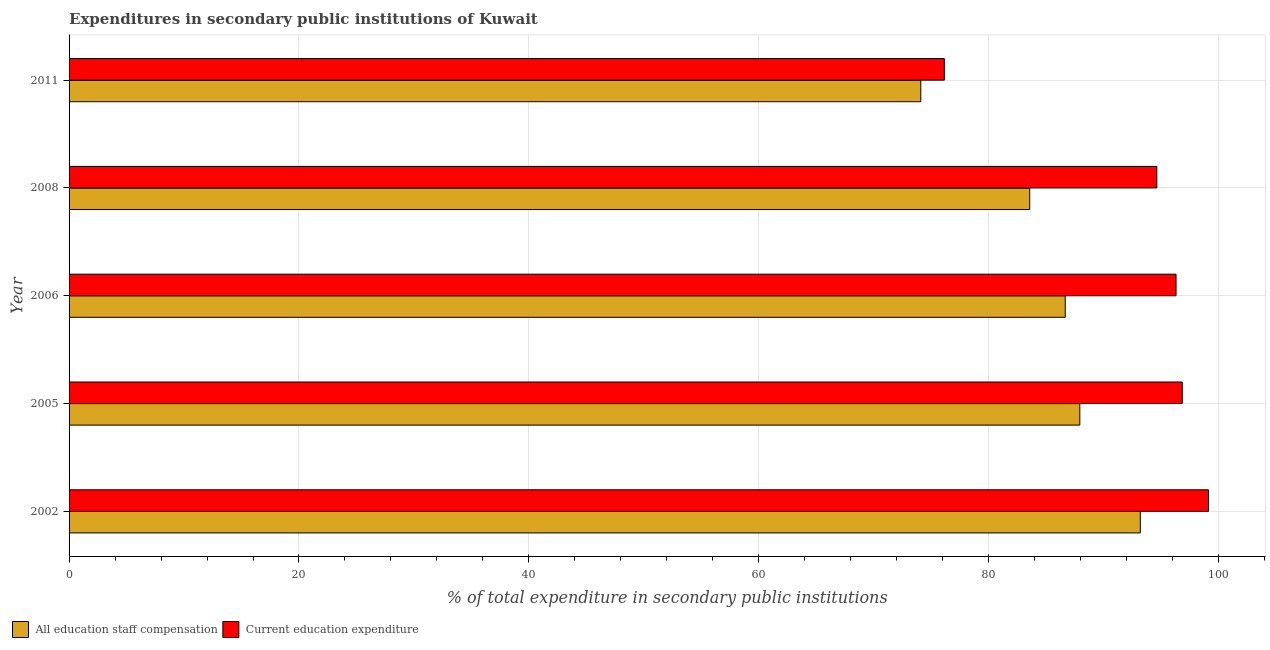How many groups of bars are there?
Offer a very short reply. 5. Are the number of bars on each tick of the Y-axis equal?
Your answer should be very brief. Yes. What is the label of the 3rd group of bars from the top?
Provide a short and direct response. 2006. In how many cases, is the number of bars for a given year not equal to the number of legend labels?
Provide a succinct answer. 0. What is the expenditure in staff compensation in 2008?
Your answer should be compact. 83.57. Across all years, what is the maximum expenditure in staff compensation?
Keep it short and to the point. 93.19. Across all years, what is the minimum expenditure in staff compensation?
Offer a very short reply. 74.09. What is the total expenditure in staff compensation in the graph?
Give a very brief answer. 425.45. What is the difference between the expenditure in education in 2008 and that in 2011?
Your answer should be compact. 18.49. What is the difference between the expenditure in education in 2002 and the expenditure in staff compensation in 2005?
Make the answer very short. 11.2. What is the average expenditure in education per year?
Offer a terse response. 92.61. In the year 2005, what is the difference between the expenditure in education and expenditure in staff compensation?
Provide a short and direct response. 8.91. In how many years, is the expenditure in staff compensation greater than 56 %?
Provide a short and direct response. 5. What is the ratio of the expenditure in staff compensation in 2006 to that in 2011?
Your response must be concise. 1.17. Is the expenditure in staff compensation in 2008 less than that in 2011?
Make the answer very short. No. Is the difference between the expenditure in education in 2006 and 2011 greater than the difference between the expenditure in staff compensation in 2006 and 2011?
Your answer should be compact. Yes. What is the difference between the highest and the second highest expenditure in education?
Your answer should be very brief. 2.28. What does the 2nd bar from the top in 2005 represents?
Your answer should be compact. All education staff compensation. What does the 1st bar from the bottom in 2011 represents?
Your answer should be compact. All education staff compensation. Are all the bars in the graph horizontal?
Keep it short and to the point. Yes. How many years are there in the graph?
Your answer should be very brief. 5. What is the difference between two consecutive major ticks on the X-axis?
Give a very brief answer. 20. Are the values on the major ticks of X-axis written in scientific E-notation?
Make the answer very short. No. Does the graph contain any zero values?
Keep it short and to the point. No. Where does the legend appear in the graph?
Your answer should be compact. Bottom left. How are the legend labels stacked?
Offer a terse response. Horizontal. What is the title of the graph?
Provide a succinct answer. Expenditures in secondary public institutions of Kuwait. Does "Non-resident workers" appear as one of the legend labels in the graph?
Offer a very short reply. No. What is the label or title of the X-axis?
Your response must be concise. % of total expenditure in secondary public institutions. What is the label or title of the Y-axis?
Keep it short and to the point. Year. What is the % of total expenditure in secondary public institutions of All education staff compensation in 2002?
Your response must be concise. 93.19. What is the % of total expenditure in secondary public institutions of Current education expenditure in 2002?
Offer a terse response. 99.12. What is the % of total expenditure in secondary public institutions in All education staff compensation in 2005?
Provide a succinct answer. 87.93. What is the % of total expenditure in secondary public institutions in Current education expenditure in 2005?
Provide a succinct answer. 96.84. What is the % of total expenditure in secondary public institutions of All education staff compensation in 2006?
Provide a succinct answer. 86.66. What is the % of total expenditure in secondary public institutions in Current education expenditure in 2006?
Your answer should be compact. 96.3. What is the % of total expenditure in secondary public institutions of All education staff compensation in 2008?
Offer a very short reply. 83.57. What is the % of total expenditure in secondary public institutions of Current education expenditure in 2008?
Provide a succinct answer. 94.63. What is the % of total expenditure in secondary public institutions of All education staff compensation in 2011?
Offer a terse response. 74.09. What is the % of total expenditure in secondary public institutions of Current education expenditure in 2011?
Make the answer very short. 76.14. Across all years, what is the maximum % of total expenditure in secondary public institutions in All education staff compensation?
Provide a short and direct response. 93.19. Across all years, what is the maximum % of total expenditure in secondary public institutions in Current education expenditure?
Give a very brief answer. 99.12. Across all years, what is the minimum % of total expenditure in secondary public institutions of All education staff compensation?
Ensure brevity in your answer.  74.09. Across all years, what is the minimum % of total expenditure in secondary public institutions in Current education expenditure?
Your response must be concise. 76.14. What is the total % of total expenditure in secondary public institutions in All education staff compensation in the graph?
Ensure brevity in your answer.  425.45. What is the total % of total expenditure in secondary public institutions of Current education expenditure in the graph?
Your answer should be very brief. 463.04. What is the difference between the % of total expenditure in secondary public institutions in All education staff compensation in 2002 and that in 2005?
Provide a succinct answer. 5.26. What is the difference between the % of total expenditure in secondary public institutions in Current education expenditure in 2002 and that in 2005?
Keep it short and to the point. 2.28. What is the difference between the % of total expenditure in secondary public institutions of All education staff compensation in 2002 and that in 2006?
Offer a very short reply. 6.53. What is the difference between the % of total expenditure in secondary public institutions in Current education expenditure in 2002 and that in 2006?
Make the answer very short. 2.83. What is the difference between the % of total expenditure in secondary public institutions of All education staff compensation in 2002 and that in 2008?
Offer a very short reply. 9.62. What is the difference between the % of total expenditure in secondary public institutions of Current education expenditure in 2002 and that in 2008?
Keep it short and to the point. 4.5. What is the difference between the % of total expenditure in secondary public institutions in All education staff compensation in 2002 and that in 2011?
Give a very brief answer. 19.1. What is the difference between the % of total expenditure in secondary public institutions in Current education expenditure in 2002 and that in 2011?
Provide a short and direct response. 22.98. What is the difference between the % of total expenditure in secondary public institutions of All education staff compensation in 2005 and that in 2006?
Make the answer very short. 1.27. What is the difference between the % of total expenditure in secondary public institutions in Current education expenditure in 2005 and that in 2006?
Your response must be concise. 0.54. What is the difference between the % of total expenditure in secondary public institutions of All education staff compensation in 2005 and that in 2008?
Your answer should be very brief. 4.36. What is the difference between the % of total expenditure in secondary public institutions of Current education expenditure in 2005 and that in 2008?
Your answer should be compact. 2.21. What is the difference between the % of total expenditure in secondary public institutions in All education staff compensation in 2005 and that in 2011?
Provide a short and direct response. 13.83. What is the difference between the % of total expenditure in secondary public institutions of Current education expenditure in 2005 and that in 2011?
Give a very brief answer. 20.7. What is the difference between the % of total expenditure in secondary public institutions of All education staff compensation in 2006 and that in 2008?
Your response must be concise. 3.09. What is the difference between the % of total expenditure in secondary public institutions in Current education expenditure in 2006 and that in 2008?
Your answer should be compact. 1.67. What is the difference between the % of total expenditure in secondary public institutions in All education staff compensation in 2006 and that in 2011?
Your response must be concise. 12.57. What is the difference between the % of total expenditure in secondary public institutions of Current education expenditure in 2006 and that in 2011?
Ensure brevity in your answer.  20.16. What is the difference between the % of total expenditure in secondary public institutions in All education staff compensation in 2008 and that in 2011?
Give a very brief answer. 9.48. What is the difference between the % of total expenditure in secondary public institutions in Current education expenditure in 2008 and that in 2011?
Keep it short and to the point. 18.49. What is the difference between the % of total expenditure in secondary public institutions of All education staff compensation in 2002 and the % of total expenditure in secondary public institutions of Current education expenditure in 2005?
Provide a short and direct response. -3.65. What is the difference between the % of total expenditure in secondary public institutions of All education staff compensation in 2002 and the % of total expenditure in secondary public institutions of Current education expenditure in 2006?
Offer a terse response. -3.11. What is the difference between the % of total expenditure in secondary public institutions in All education staff compensation in 2002 and the % of total expenditure in secondary public institutions in Current education expenditure in 2008?
Your answer should be very brief. -1.44. What is the difference between the % of total expenditure in secondary public institutions of All education staff compensation in 2002 and the % of total expenditure in secondary public institutions of Current education expenditure in 2011?
Offer a very short reply. 17.05. What is the difference between the % of total expenditure in secondary public institutions of All education staff compensation in 2005 and the % of total expenditure in secondary public institutions of Current education expenditure in 2006?
Your answer should be very brief. -8.37. What is the difference between the % of total expenditure in secondary public institutions of All education staff compensation in 2005 and the % of total expenditure in secondary public institutions of Current education expenditure in 2008?
Provide a succinct answer. -6.7. What is the difference between the % of total expenditure in secondary public institutions in All education staff compensation in 2005 and the % of total expenditure in secondary public institutions in Current education expenditure in 2011?
Ensure brevity in your answer.  11.79. What is the difference between the % of total expenditure in secondary public institutions of All education staff compensation in 2006 and the % of total expenditure in secondary public institutions of Current education expenditure in 2008?
Your answer should be very brief. -7.97. What is the difference between the % of total expenditure in secondary public institutions in All education staff compensation in 2006 and the % of total expenditure in secondary public institutions in Current education expenditure in 2011?
Your answer should be very brief. 10.52. What is the difference between the % of total expenditure in secondary public institutions of All education staff compensation in 2008 and the % of total expenditure in secondary public institutions of Current education expenditure in 2011?
Offer a very short reply. 7.43. What is the average % of total expenditure in secondary public institutions in All education staff compensation per year?
Provide a succinct answer. 85.09. What is the average % of total expenditure in secondary public institutions in Current education expenditure per year?
Your answer should be very brief. 92.61. In the year 2002, what is the difference between the % of total expenditure in secondary public institutions in All education staff compensation and % of total expenditure in secondary public institutions in Current education expenditure?
Your answer should be very brief. -5.93. In the year 2005, what is the difference between the % of total expenditure in secondary public institutions in All education staff compensation and % of total expenditure in secondary public institutions in Current education expenditure?
Your response must be concise. -8.91. In the year 2006, what is the difference between the % of total expenditure in secondary public institutions in All education staff compensation and % of total expenditure in secondary public institutions in Current education expenditure?
Give a very brief answer. -9.64. In the year 2008, what is the difference between the % of total expenditure in secondary public institutions in All education staff compensation and % of total expenditure in secondary public institutions in Current education expenditure?
Your answer should be compact. -11.06. In the year 2011, what is the difference between the % of total expenditure in secondary public institutions of All education staff compensation and % of total expenditure in secondary public institutions of Current education expenditure?
Offer a terse response. -2.05. What is the ratio of the % of total expenditure in secondary public institutions in All education staff compensation in 2002 to that in 2005?
Keep it short and to the point. 1.06. What is the ratio of the % of total expenditure in secondary public institutions of Current education expenditure in 2002 to that in 2005?
Make the answer very short. 1.02. What is the ratio of the % of total expenditure in secondary public institutions of All education staff compensation in 2002 to that in 2006?
Provide a short and direct response. 1.08. What is the ratio of the % of total expenditure in secondary public institutions in Current education expenditure in 2002 to that in 2006?
Ensure brevity in your answer.  1.03. What is the ratio of the % of total expenditure in secondary public institutions of All education staff compensation in 2002 to that in 2008?
Provide a short and direct response. 1.12. What is the ratio of the % of total expenditure in secondary public institutions of Current education expenditure in 2002 to that in 2008?
Offer a very short reply. 1.05. What is the ratio of the % of total expenditure in secondary public institutions of All education staff compensation in 2002 to that in 2011?
Give a very brief answer. 1.26. What is the ratio of the % of total expenditure in secondary public institutions of Current education expenditure in 2002 to that in 2011?
Give a very brief answer. 1.3. What is the ratio of the % of total expenditure in secondary public institutions of All education staff compensation in 2005 to that in 2006?
Your response must be concise. 1.01. What is the ratio of the % of total expenditure in secondary public institutions in Current education expenditure in 2005 to that in 2006?
Provide a short and direct response. 1.01. What is the ratio of the % of total expenditure in secondary public institutions of All education staff compensation in 2005 to that in 2008?
Give a very brief answer. 1.05. What is the ratio of the % of total expenditure in secondary public institutions of Current education expenditure in 2005 to that in 2008?
Keep it short and to the point. 1.02. What is the ratio of the % of total expenditure in secondary public institutions of All education staff compensation in 2005 to that in 2011?
Offer a very short reply. 1.19. What is the ratio of the % of total expenditure in secondary public institutions in Current education expenditure in 2005 to that in 2011?
Provide a short and direct response. 1.27. What is the ratio of the % of total expenditure in secondary public institutions in All education staff compensation in 2006 to that in 2008?
Offer a terse response. 1.04. What is the ratio of the % of total expenditure in secondary public institutions in Current education expenditure in 2006 to that in 2008?
Your answer should be very brief. 1.02. What is the ratio of the % of total expenditure in secondary public institutions in All education staff compensation in 2006 to that in 2011?
Keep it short and to the point. 1.17. What is the ratio of the % of total expenditure in secondary public institutions in Current education expenditure in 2006 to that in 2011?
Provide a succinct answer. 1.26. What is the ratio of the % of total expenditure in secondary public institutions in All education staff compensation in 2008 to that in 2011?
Ensure brevity in your answer.  1.13. What is the ratio of the % of total expenditure in secondary public institutions in Current education expenditure in 2008 to that in 2011?
Your answer should be very brief. 1.24. What is the difference between the highest and the second highest % of total expenditure in secondary public institutions in All education staff compensation?
Offer a terse response. 5.26. What is the difference between the highest and the second highest % of total expenditure in secondary public institutions of Current education expenditure?
Make the answer very short. 2.28. What is the difference between the highest and the lowest % of total expenditure in secondary public institutions of All education staff compensation?
Make the answer very short. 19.1. What is the difference between the highest and the lowest % of total expenditure in secondary public institutions in Current education expenditure?
Provide a short and direct response. 22.98. 